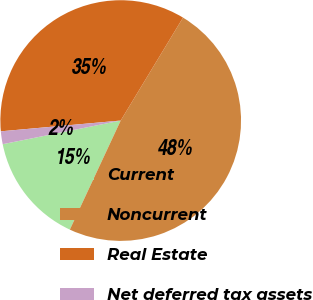Convert chart. <chart><loc_0><loc_0><loc_500><loc_500><pie_chart><fcel>Current<fcel>Noncurrent<fcel>Real Estate<fcel>Net deferred tax assets<nl><fcel>14.91%<fcel>48.28%<fcel>35.09%<fcel>1.72%<nl></chart> 